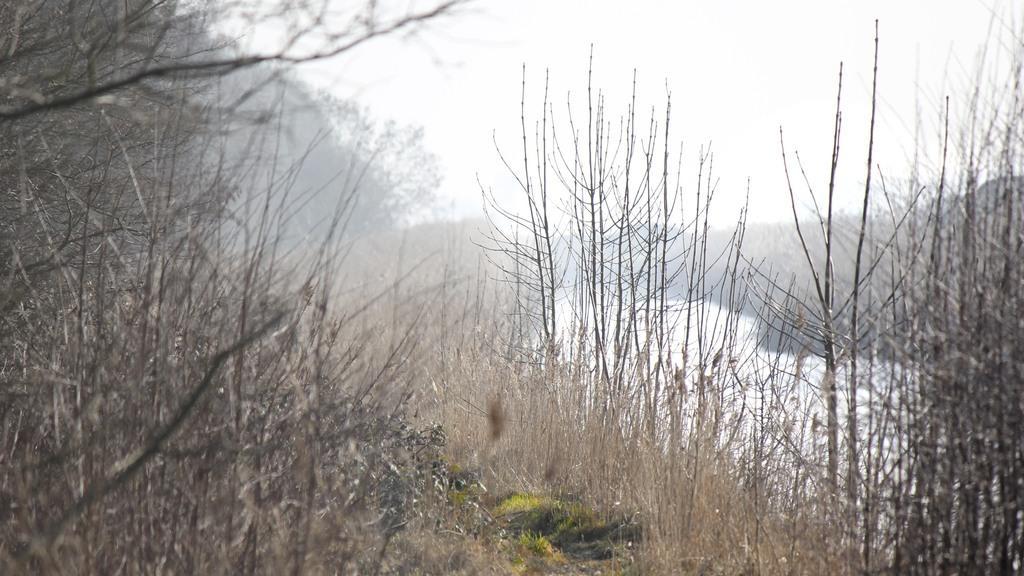Describe this image in one or two sentences. In this image, we can see some dry plants. There is a river on the right side of the image. There is a sky at the top of the image. 